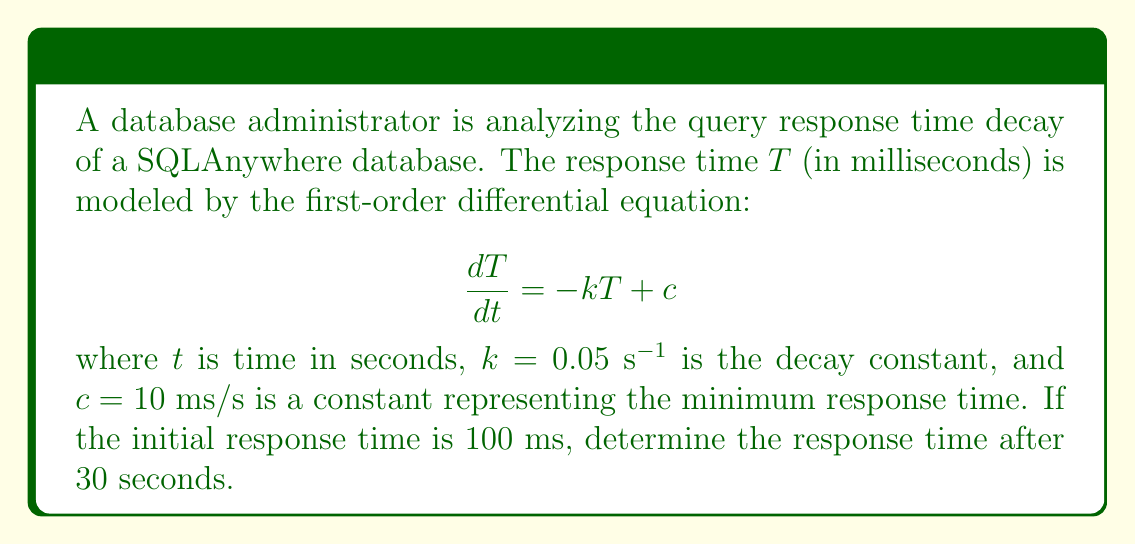Provide a solution to this math problem. To solve this first-order linear differential equation, we follow these steps:

1) The general solution for this type of equation is:

   $$T(t) = \frac{c}{k} + Ae^{-kt}$$

   where $A$ is a constant determined by the initial condition.

2) Given the initial condition $T(0) = 100$ ms, we can find $A$:

   $$100 = \frac{10}{0.05} + A$$
   $$100 = 200 + A$$
   $$A = -100$$

3) Now we have the particular solution:

   $$T(t) = 200 - 100e^{-0.05t}$$

4) To find the response time after 30 seconds, we evaluate $T(30)$:

   $$T(30) = 200 - 100e^{-0.05(30)}$$
   $$= 200 - 100e^{-1.5}$$
   $$= 200 - 100(0.2231)$$
   $$= 200 - 22.31$$
   $$= 177.69$$

5) Rounding to two decimal places:

   $$T(30) \approx 177.69 \text{ ms}$$

This result shows how the response time decays from the initial 100 ms towards the asymptotic value of 200 ms (c/k) over time.
Answer: 177.69 ms 